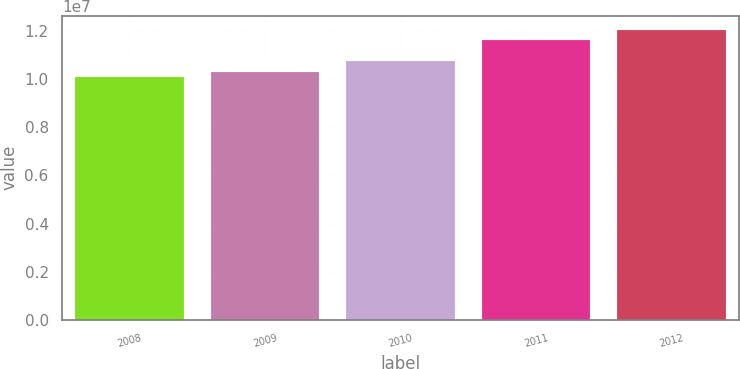Convert chart. <chart><loc_0><loc_0><loc_500><loc_500><bar_chart><fcel>2008<fcel>2009<fcel>2010<fcel>2011<fcel>2012<nl><fcel>1.0093e+07<fcel>1.02881e+07<fcel>1.0781e+07<fcel>1.1625e+07<fcel>1.2044e+07<nl></chart> 